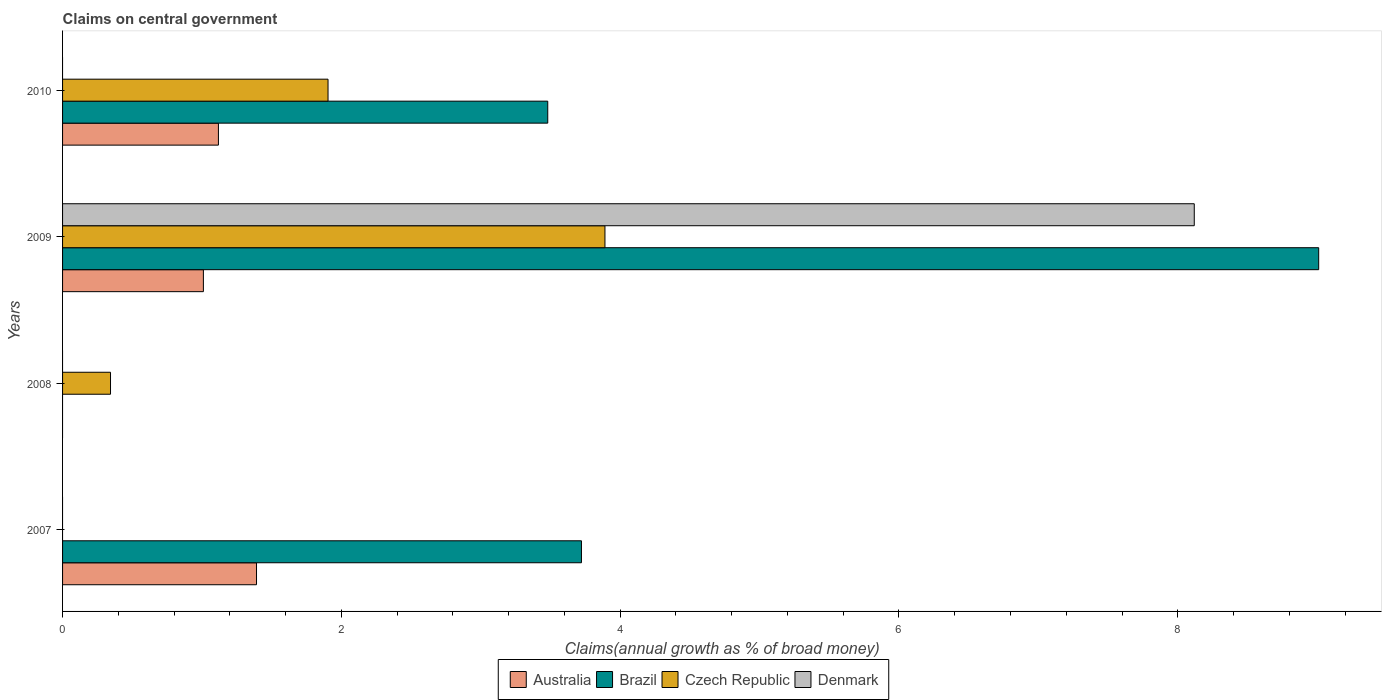How many different coloured bars are there?
Provide a short and direct response. 4. In how many cases, is the number of bars for a given year not equal to the number of legend labels?
Provide a short and direct response. 3. What is the percentage of broad money claimed on centeral government in Brazil in 2010?
Give a very brief answer. 3.48. Across all years, what is the maximum percentage of broad money claimed on centeral government in Denmark?
Your answer should be very brief. 8.12. In which year was the percentage of broad money claimed on centeral government in Denmark maximum?
Your answer should be compact. 2009. What is the total percentage of broad money claimed on centeral government in Czech Republic in the graph?
Ensure brevity in your answer.  6.14. What is the difference between the percentage of broad money claimed on centeral government in Australia in 2007 and that in 2010?
Provide a short and direct response. 0.27. What is the difference between the percentage of broad money claimed on centeral government in Brazil in 2009 and the percentage of broad money claimed on centeral government in Denmark in 2008?
Your answer should be compact. 9.01. What is the average percentage of broad money claimed on centeral government in Brazil per year?
Your answer should be very brief. 4.05. In the year 2010, what is the difference between the percentage of broad money claimed on centeral government in Australia and percentage of broad money claimed on centeral government in Czech Republic?
Your answer should be compact. -0.79. In how many years, is the percentage of broad money claimed on centeral government in Denmark greater than 0.8 %?
Offer a terse response. 1. What is the ratio of the percentage of broad money claimed on centeral government in Brazil in 2007 to that in 2010?
Provide a short and direct response. 1.07. Is the percentage of broad money claimed on centeral government in Czech Republic in 2009 less than that in 2010?
Your response must be concise. No. What is the difference between the highest and the second highest percentage of broad money claimed on centeral government in Czech Republic?
Ensure brevity in your answer.  1.99. What is the difference between the highest and the lowest percentage of broad money claimed on centeral government in Brazil?
Your answer should be compact. 9.01. Is the sum of the percentage of broad money claimed on centeral government in Australia in 2007 and 2009 greater than the maximum percentage of broad money claimed on centeral government in Brazil across all years?
Your answer should be compact. No. How many years are there in the graph?
Provide a succinct answer. 4. Does the graph contain any zero values?
Provide a short and direct response. Yes. Where does the legend appear in the graph?
Provide a succinct answer. Bottom center. How many legend labels are there?
Offer a terse response. 4. How are the legend labels stacked?
Your answer should be very brief. Horizontal. What is the title of the graph?
Offer a very short reply. Claims on central government. What is the label or title of the X-axis?
Keep it short and to the point. Claims(annual growth as % of broad money). What is the Claims(annual growth as % of broad money) of Australia in 2007?
Ensure brevity in your answer.  1.39. What is the Claims(annual growth as % of broad money) of Brazil in 2007?
Give a very brief answer. 3.72. What is the Claims(annual growth as % of broad money) in Denmark in 2007?
Offer a very short reply. 0. What is the Claims(annual growth as % of broad money) in Czech Republic in 2008?
Your response must be concise. 0.34. What is the Claims(annual growth as % of broad money) in Denmark in 2008?
Provide a short and direct response. 0. What is the Claims(annual growth as % of broad money) of Australia in 2009?
Keep it short and to the point. 1.01. What is the Claims(annual growth as % of broad money) in Brazil in 2009?
Provide a succinct answer. 9.01. What is the Claims(annual growth as % of broad money) in Czech Republic in 2009?
Your answer should be compact. 3.89. What is the Claims(annual growth as % of broad money) of Denmark in 2009?
Offer a very short reply. 8.12. What is the Claims(annual growth as % of broad money) of Australia in 2010?
Your response must be concise. 1.12. What is the Claims(annual growth as % of broad money) in Brazil in 2010?
Give a very brief answer. 3.48. What is the Claims(annual growth as % of broad money) in Czech Republic in 2010?
Provide a short and direct response. 1.9. Across all years, what is the maximum Claims(annual growth as % of broad money) in Australia?
Offer a very short reply. 1.39. Across all years, what is the maximum Claims(annual growth as % of broad money) in Brazil?
Your answer should be compact. 9.01. Across all years, what is the maximum Claims(annual growth as % of broad money) of Czech Republic?
Offer a terse response. 3.89. Across all years, what is the maximum Claims(annual growth as % of broad money) of Denmark?
Give a very brief answer. 8.12. Across all years, what is the minimum Claims(annual growth as % of broad money) in Australia?
Provide a short and direct response. 0. Across all years, what is the minimum Claims(annual growth as % of broad money) of Brazil?
Provide a short and direct response. 0. Across all years, what is the minimum Claims(annual growth as % of broad money) of Czech Republic?
Offer a terse response. 0. What is the total Claims(annual growth as % of broad money) of Australia in the graph?
Make the answer very short. 3.52. What is the total Claims(annual growth as % of broad money) of Brazil in the graph?
Provide a succinct answer. 16.21. What is the total Claims(annual growth as % of broad money) in Czech Republic in the graph?
Offer a very short reply. 6.14. What is the total Claims(annual growth as % of broad money) of Denmark in the graph?
Make the answer very short. 8.12. What is the difference between the Claims(annual growth as % of broad money) in Australia in 2007 and that in 2009?
Make the answer very short. 0.38. What is the difference between the Claims(annual growth as % of broad money) in Brazil in 2007 and that in 2009?
Your answer should be very brief. -5.29. What is the difference between the Claims(annual growth as % of broad money) in Australia in 2007 and that in 2010?
Ensure brevity in your answer.  0.27. What is the difference between the Claims(annual growth as % of broad money) in Brazil in 2007 and that in 2010?
Give a very brief answer. 0.24. What is the difference between the Claims(annual growth as % of broad money) of Czech Republic in 2008 and that in 2009?
Your answer should be very brief. -3.55. What is the difference between the Claims(annual growth as % of broad money) of Czech Republic in 2008 and that in 2010?
Your answer should be very brief. -1.56. What is the difference between the Claims(annual growth as % of broad money) of Australia in 2009 and that in 2010?
Offer a terse response. -0.11. What is the difference between the Claims(annual growth as % of broad money) in Brazil in 2009 and that in 2010?
Keep it short and to the point. 5.53. What is the difference between the Claims(annual growth as % of broad money) of Czech Republic in 2009 and that in 2010?
Make the answer very short. 1.99. What is the difference between the Claims(annual growth as % of broad money) of Australia in 2007 and the Claims(annual growth as % of broad money) of Czech Republic in 2008?
Your answer should be compact. 1.05. What is the difference between the Claims(annual growth as % of broad money) in Brazil in 2007 and the Claims(annual growth as % of broad money) in Czech Republic in 2008?
Ensure brevity in your answer.  3.38. What is the difference between the Claims(annual growth as % of broad money) of Australia in 2007 and the Claims(annual growth as % of broad money) of Brazil in 2009?
Your answer should be compact. -7.62. What is the difference between the Claims(annual growth as % of broad money) of Australia in 2007 and the Claims(annual growth as % of broad money) of Czech Republic in 2009?
Make the answer very short. -2.5. What is the difference between the Claims(annual growth as % of broad money) of Australia in 2007 and the Claims(annual growth as % of broad money) of Denmark in 2009?
Your response must be concise. -6.73. What is the difference between the Claims(annual growth as % of broad money) in Brazil in 2007 and the Claims(annual growth as % of broad money) in Czech Republic in 2009?
Your response must be concise. -0.17. What is the difference between the Claims(annual growth as % of broad money) in Brazil in 2007 and the Claims(annual growth as % of broad money) in Denmark in 2009?
Offer a very short reply. -4.4. What is the difference between the Claims(annual growth as % of broad money) of Australia in 2007 and the Claims(annual growth as % of broad money) of Brazil in 2010?
Make the answer very short. -2.09. What is the difference between the Claims(annual growth as % of broad money) in Australia in 2007 and the Claims(annual growth as % of broad money) in Czech Republic in 2010?
Give a very brief answer. -0.51. What is the difference between the Claims(annual growth as % of broad money) in Brazil in 2007 and the Claims(annual growth as % of broad money) in Czech Republic in 2010?
Offer a very short reply. 1.82. What is the difference between the Claims(annual growth as % of broad money) of Czech Republic in 2008 and the Claims(annual growth as % of broad money) of Denmark in 2009?
Offer a very short reply. -7.77. What is the difference between the Claims(annual growth as % of broad money) in Australia in 2009 and the Claims(annual growth as % of broad money) in Brazil in 2010?
Offer a terse response. -2.47. What is the difference between the Claims(annual growth as % of broad money) of Australia in 2009 and the Claims(annual growth as % of broad money) of Czech Republic in 2010?
Your response must be concise. -0.89. What is the difference between the Claims(annual growth as % of broad money) in Brazil in 2009 and the Claims(annual growth as % of broad money) in Czech Republic in 2010?
Your answer should be compact. 7.11. What is the average Claims(annual growth as % of broad money) in Australia per year?
Ensure brevity in your answer.  0.88. What is the average Claims(annual growth as % of broad money) of Brazil per year?
Provide a succinct answer. 4.05. What is the average Claims(annual growth as % of broad money) in Czech Republic per year?
Make the answer very short. 1.53. What is the average Claims(annual growth as % of broad money) in Denmark per year?
Provide a short and direct response. 2.03. In the year 2007, what is the difference between the Claims(annual growth as % of broad money) in Australia and Claims(annual growth as % of broad money) in Brazil?
Give a very brief answer. -2.33. In the year 2009, what is the difference between the Claims(annual growth as % of broad money) in Australia and Claims(annual growth as % of broad money) in Brazil?
Give a very brief answer. -8. In the year 2009, what is the difference between the Claims(annual growth as % of broad money) in Australia and Claims(annual growth as % of broad money) in Czech Republic?
Offer a terse response. -2.88. In the year 2009, what is the difference between the Claims(annual growth as % of broad money) of Australia and Claims(annual growth as % of broad money) of Denmark?
Your response must be concise. -7.11. In the year 2009, what is the difference between the Claims(annual growth as % of broad money) of Brazil and Claims(annual growth as % of broad money) of Czech Republic?
Give a very brief answer. 5.12. In the year 2009, what is the difference between the Claims(annual growth as % of broad money) of Brazil and Claims(annual growth as % of broad money) of Denmark?
Keep it short and to the point. 0.89. In the year 2009, what is the difference between the Claims(annual growth as % of broad money) of Czech Republic and Claims(annual growth as % of broad money) of Denmark?
Offer a very short reply. -4.23. In the year 2010, what is the difference between the Claims(annual growth as % of broad money) in Australia and Claims(annual growth as % of broad money) in Brazil?
Keep it short and to the point. -2.36. In the year 2010, what is the difference between the Claims(annual growth as % of broad money) in Australia and Claims(annual growth as % of broad money) in Czech Republic?
Offer a terse response. -0.79. In the year 2010, what is the difference between the Claims(annual growth as % of broad money) in Brazil and Claims(annual growth as % of broad money) in Czech Republic?
Keep it short and to the point. 1.58. What is the ratio of the Claims(annual growth as % of broad money) of Australia in 2007 to that in 2009?
Make the answer very short. 1.38. What is the ratio of the Claims(annual growth as % of broad money) in Brazil in 2007 to that in 2009?
Provide a short and direct response. 0.41. What is the ratio of the Claims(annual growth as % of broad money) of Australia in 2007 to that in 2010?
Give a very brief answer. 1.24. What is the ratio of the Claims(annual growth as % of broad money) in Brazil in 2007 to that in 2010?
Keep it short and to the point. 1.07. What is the ratio of the Claims(annual growth as % of broad money) of Czech Republic in 2008 to that in 2009?
Offer a terse response. 0.09. What is the ratio of the Claims(annual growth as % of broad money) in Czech Republic in 2008 to that in 2010?
Make the answer very short. 0.18. What is the ratio of the Claims(annual growth as % of broad money) of Australia in 2009 to that in 2010?
Offer a very short reply. 0.9. What is the ratio of the Claims(annual growth as % of broad money) in Brazil in 2009 to that in 2010?
Offer a very short reply. 2.59. What is the ratio of the Claims(annual growth as % of broad money) in Czech Republic in 2009 to that in 2010?
Ensure brevity in your answer.  2.04. What is the difference between the highest and the second highest Claims(annual growth as % of broad money) of Australia?
Make the answer very short. 0.27. What is the difference between the highest and the second highest Claims(annual growth as % of broad money) of Brazil?
Make the answer very short. 5.29. What is the difference between the highest and the second highest Claims(annual growth as % of broad money) of Czech Republic?
Your answer should be very brief. 1.99. What is the difference between the highest and the lowest Claims(annual growth as % of broad money) in Australia?
Make the answer very short. 1.39. What is the difference between the highest and the lowest Claims(annual growth as % of broad money) in Brazil?
Give a very brief answer. 9.01. What is the difference between the highest and the lowest Claims(annual growth as % of broad money) in Czech Republic?
Ensure brevity in your answer.  3.89. What is the difference between the highest and the lowest Claims(annual growth as % of broad money) of Denmark?
Provide a succinct answer. 8.12. 